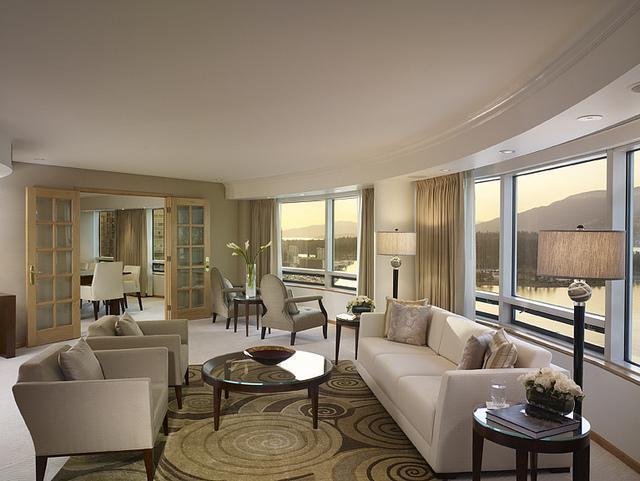How many couches can you see?
Give a very brief answer. 2. How many chairs are visible?
Give a very brief answer. 3. 